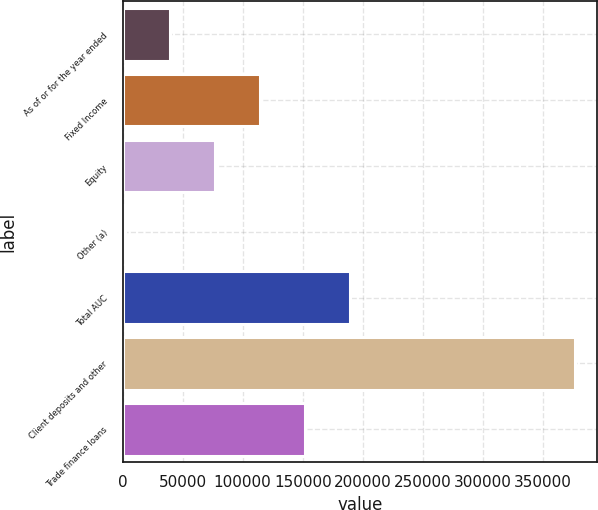Convert chart. <chart><loc_0><loc_0><loc_500><loc_500><bar_chart><fcel>As of or for the year ended<fcel>Fixed Income<fcel>Equity<fcel>Other (a)<fcel>Total AUC<fcel>Client deposits and other<fcel>Trade finance loans<nl><fcel>39362.1<fcel>114234<fcel>76798.2<fcel>1926<fcel>189106<fcel>376287<fcel>151670<nl></chart> 